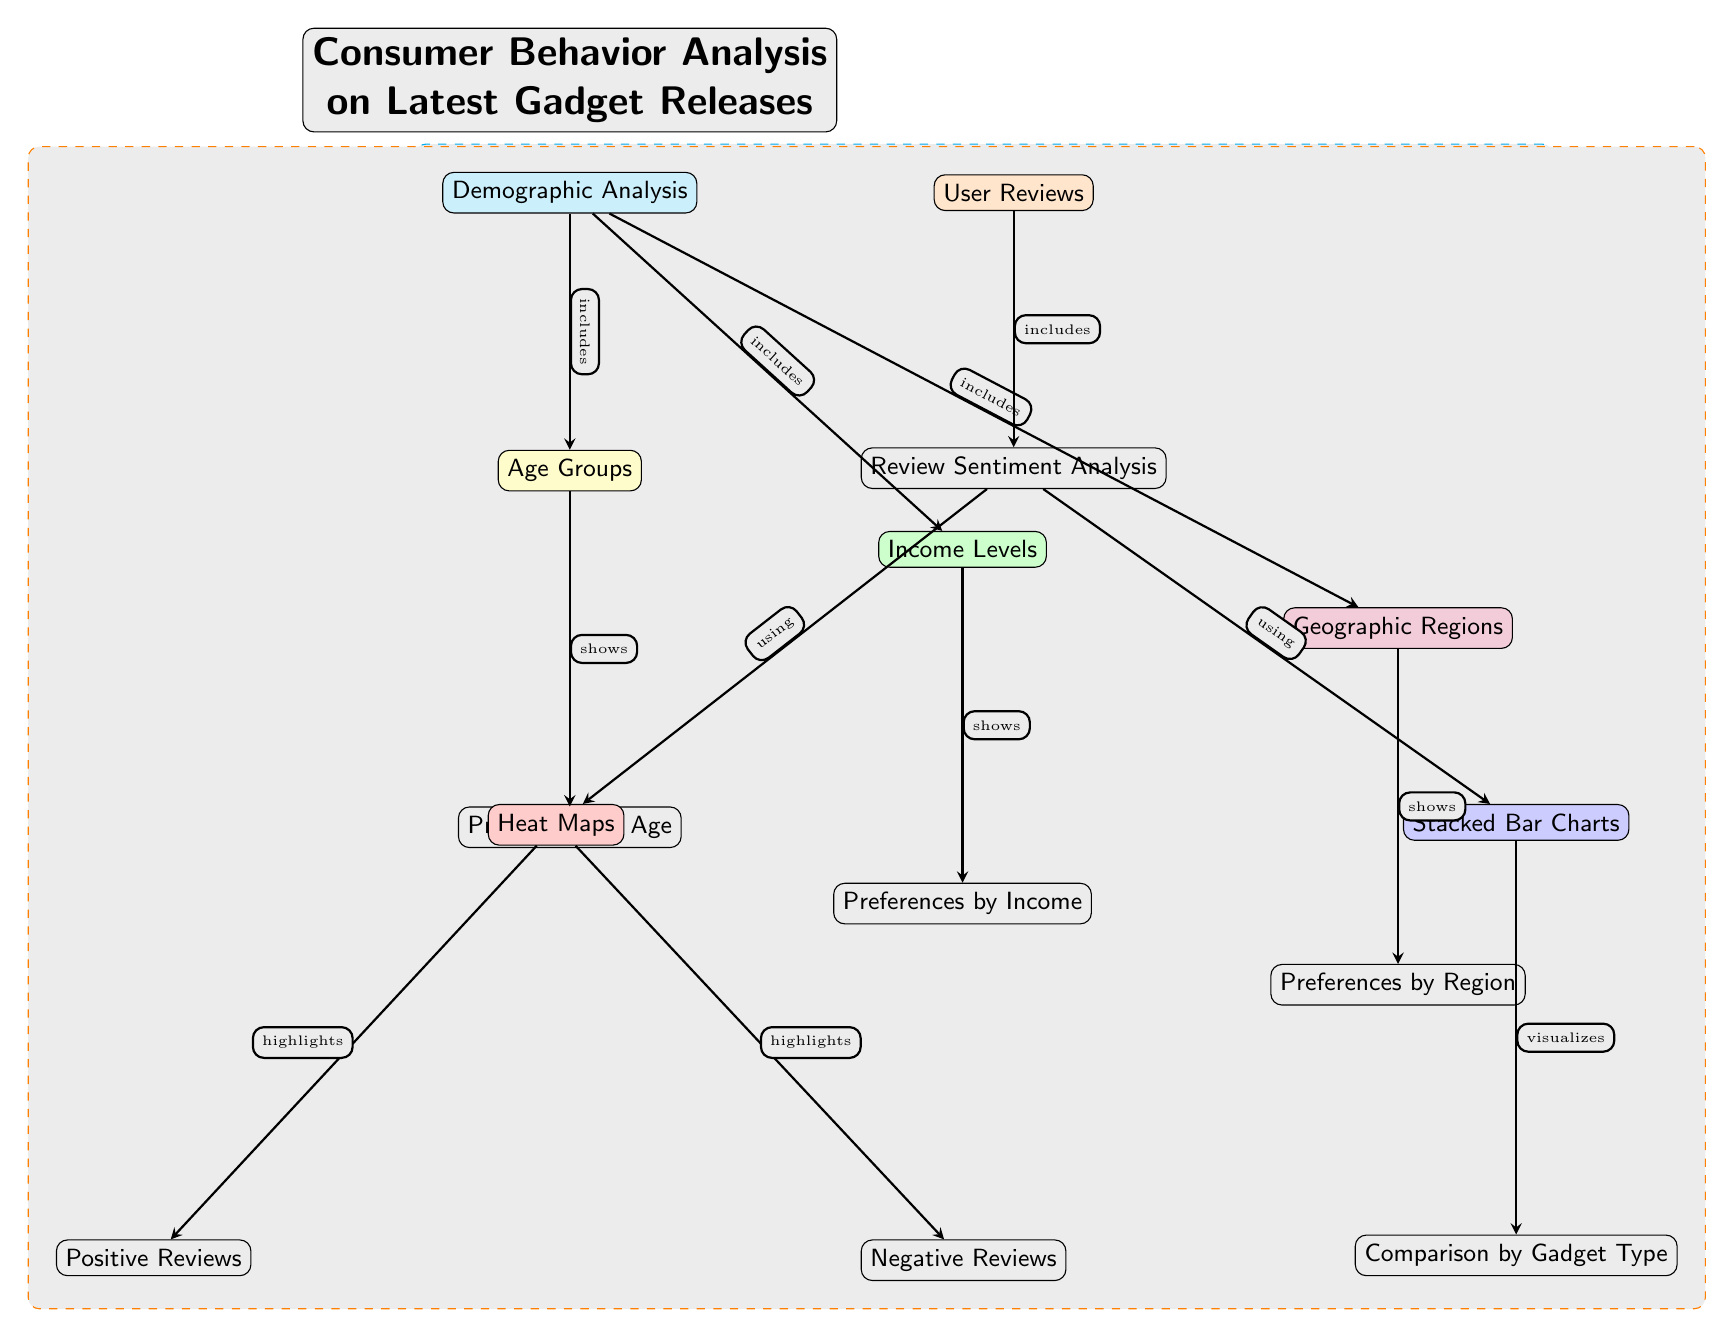What are the two main components analyzed in this diagram? The diagram clearly indicates that it focuses on "Demographic Analysis" and "User Reviews," which are positioned at the top as the primary sections of the analysis.
Answer: Demographic Analysis, User Reviews How many demographic categories are detailed in the diagram? The diagram lists three demographic categories: "Age Groups," "Income Levels," and "Geographic Regions," which are shown under the "Demographic Analysis" section.
Answer: Three What type of visual representation is used for user reviews? The diagram specifies that User Reviews utilize "Heat Maps" and "Stacked Bar Charts" to visualize the data, as denoted under the "Review Sentiment Analysis" section.
Answer: Heat Maps, Stacked Bar Charts Which demographic category includes preferences by age? The diagram shows that "Preferences by Age" is directly associated with the "Age Groups" node, indicating it falls under demographic analysis concerning age.
Answer: Preferences by Age What do "Heat Maps" highlight according to the diagram? "Heat Maps" in the diagram highlight both "Positive Reviews" and "Negative Reviews," clearly indicating the outcomes of their analysis related to user sentiment.
Answer: Positive Reviews, Negative Reviews How does "Comparison by Gadget Type" relate to user reviews? "Comparison by Gadget Type" is depicted as a visualization method (Stacked Bar Charts) that directly derives from the "Review Sentiment Analysis," showing the relationship between gadget types and user reviews.
Answer: Visualization of gadget types Which demographic category is shown to have preferences by region? Under the "Geographic Regions" section, the diagram indicates that there are "Preferences by Region," showcasing a specific demographic analysis related to geographic factors.
Answer: Preferences by Region What is included in the edges connecting "Demographic Analysis" to its subcategories? The edges indicate that "Demographic Analysis" includes subcategories, and each subcategory edge shows the type of information derived, labeled as "includes" for each linkage to additional details.
Answer: Includes Which node is located below the "User Reviews" section? The "Review Sentiment Analysis" node is positioned directly below the "User Reviews," demonstrating a clear hierarchy in the content presented in the diagram.
Answer: Review Sentiment Analysis 